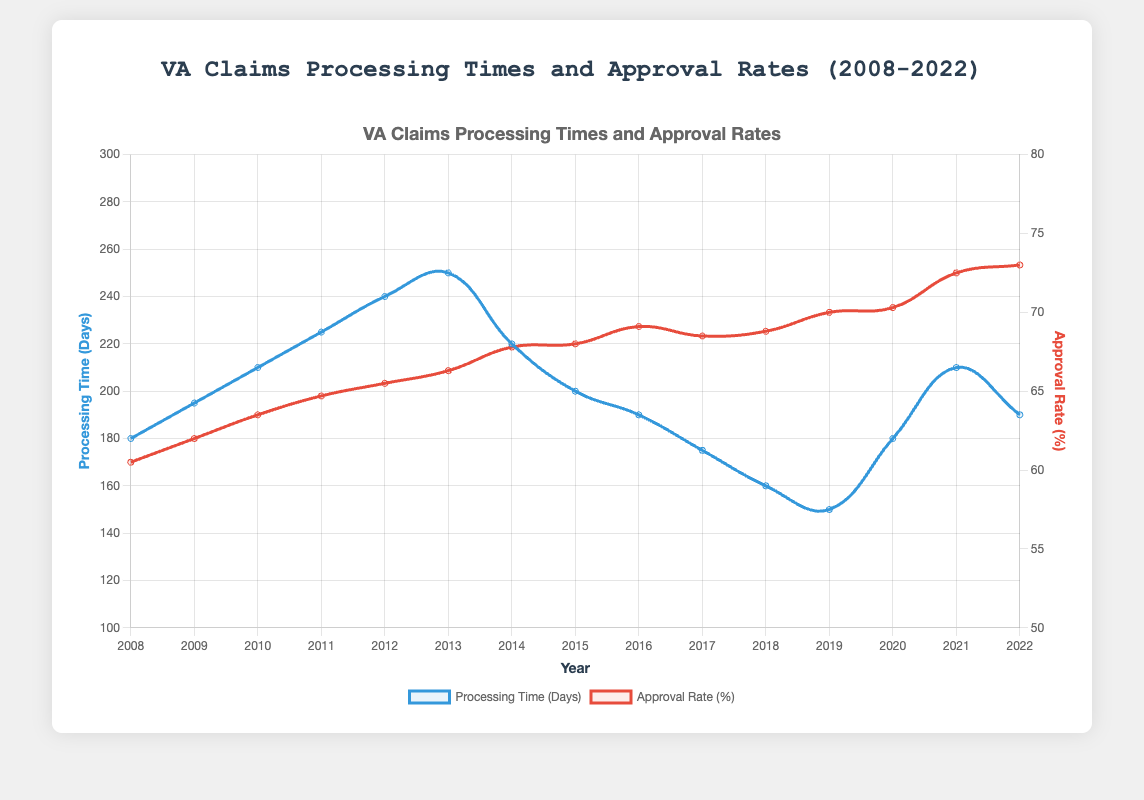What is the median processing time in days over the entire period from 2008 to 2022? To find the median, arrange the processing times in ascending order: [150, 160, 175, 180, 180, 190, 190, 195, 200, 210, 210, 220, 225, 240, 250]. The median value (middle number) of these 15 values is the 8th number, which is 195.
Answer: 195 In which year was the processing time the shortest, and what was the processing time? By examining the graph, the shortest processing time occurred in 2019 with an average of 150 days.
Answer: 2019, 150 days How does the approval rate in 2022 compare to the approval rate in 2008? The approval rate in 2022 was 73.0%, whereas in 2008 it was 60.5%. Subtracting 60.5% from 73.0%, the increase is 12.5 percentage points.
Answer: Increased by 12.5 percentage points During which year or years did the processing time experience an increase compared to the previous year? By examining the graph: 
- From 2008 to 2009 (180 to 195)
- From 2009 to 2010 (195 to 210)
- From 2010 to 2011 (210 to 225)
- From 2011 to 2012 (225 to 240)
- From 2012 to 2013 (240 to 250)
- From 2018 to 2019 (150 to 180)
- From 2019 to 2020 (180 to 210)
Answer: 2009, 2010, 2011, 2012, 2013, 2019, 2020 What is the difference between the highest and lowest approval rates recorded from 2008 to 2022? The highest approval rate is 73.0% (2022) and the lowest is 60.5% (2008). The difference is 73.0 - 60.5 = 12.5 percentage points.
Answer: 12.5 percentage points In which year did the processing time and approval rate have the greatest disparity? The greatest disparity between processing time and approval rate can be noted as the year 2020 where the approval rate was relatively high (70.3%) while the processing time jumped to 210 days.
Answer: 2020 What trend can be observed in both the processing times and the approval rates from 2008 to 2022? Over the period from 2008 to 2022, the processing time generally increased initially, peaked around 2013, and then decreased with some fluctuations. Approval rates gradually increased over the entire period.
Answer: Increasing approval rates, but fluctuating processing times How did the processing time in 2015 compare to that in 2013? The processing time in 2013 was 250 days and in 2015 it was 200 days. The processing time decreased by 50 days.
Answer: Decreased by 50 days Identify the consistent trend, if any, in the approval rates during the years from 2010 to 2018? Over the years from 2010 to 2018, the approval rates consistently increased each year, from 63.5% in 2010 to 68.8% in 2018.
Answer: Consistently increasing 